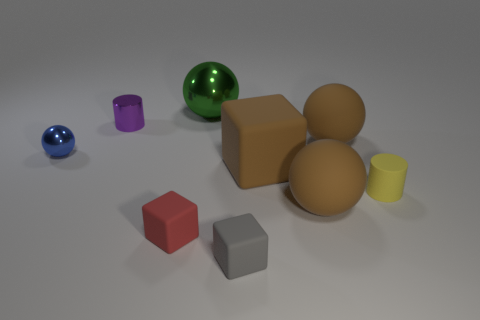Subtract all small blocks. How many blocks are left? 1 Subtract all red cylinders. How many brown balls are left? 2 Subtract all green balls. How many balls are left? 3 Subtract all cylinders. How many objects are left? 7 Add 1 big brown rubber balls. How many objects exist? 10 Subtract 0 green cylinders. How many objects are left? 9 Subtract 2 cylinders. How many cylinders are left? 0 Subtract all gray balls. Subtract all green blocks. How many balls are left? 4 Subtract all tiny purple balls. Subtract all tiny yellow things. How many objects are left? 8 Add 6 tiny shiny objects. How many tiny shiny objects are left? 8 